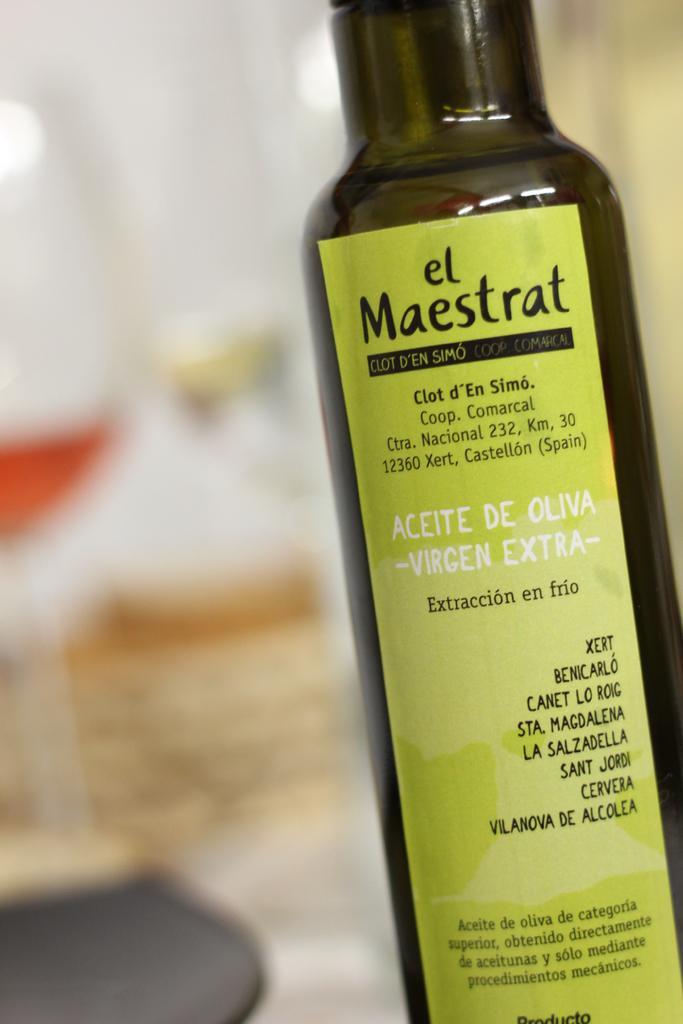In one or two sentences, can you explain what this image depicts? in a picture there is a bottle with sticker on it. 